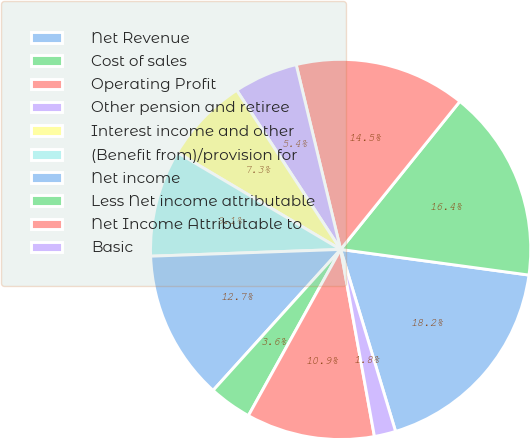<chart> <loc_0><loc_0><loc_500><loc_500><pie_chart><fcel>Net Revenue<fcel>Cost of sales<fcel>Operating Profit<fcel>Other pension and retiree<fcel>Interest income and other<fcel>(Benefit from)/provision for<fcel>Net income<fcel>Less Net income attributable<fcel>Net Income Attributable to<fcel>Basic<nl><fcel>18.18%<fcel>16.36%<fcel>14.55%<fcel>5.45%<fcel>7.27%<fcel>9.09%<fcel>12.73%<fcel>3.64%<fcel>10.91%<fcel>1.82%<nl></chart> 